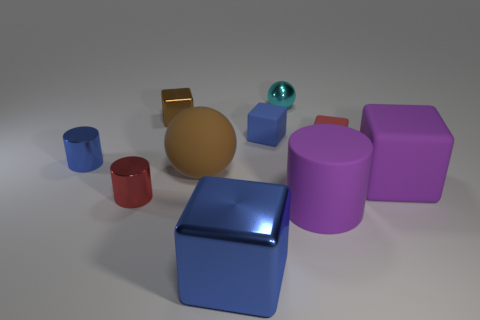Is the number of purple cylinders behind the big cylinder less than the number of big brown balls?
Ensure brevity in your answer.  Yes. The small object that is left of the tiny metallic object that is in front of the small cylinder behind the big purple rubber block is what color?
Make the answer very short. Blue. Is there any other thing that is made of the same material as the big purple block?
Make the answer very short. Yes. What size is the red shiny thing that is the same shape as the tiny blue metal thing?
Give a very brief answer. Small. Is the number of big things that are behind the red metallic object less than the number of large purple rubber objects behind the tiny cyan object?
Offer a very short reply. No. What is the shape of the metallic object that is both behind the purple cube and in front of the tiny brown shiny thing?
Make the answer very short. Cylinder. There is a sphere that is the same material as the brown cube; what size is it?
Give a very brief answer. Small. There is a large matte ball; is its color the same as the shiny cylinder that is behind the red cylinder?
Ensure brevity in your answer.  No. The large thing that is left of the rubber cylinder and behind the big purple cylinder is made of what material?
Your answer should be very brief. Rubber. There is a rubber block that is the same color as the big matte cylinder; what size is it?
Ensure brevity in your answer.  Large. 